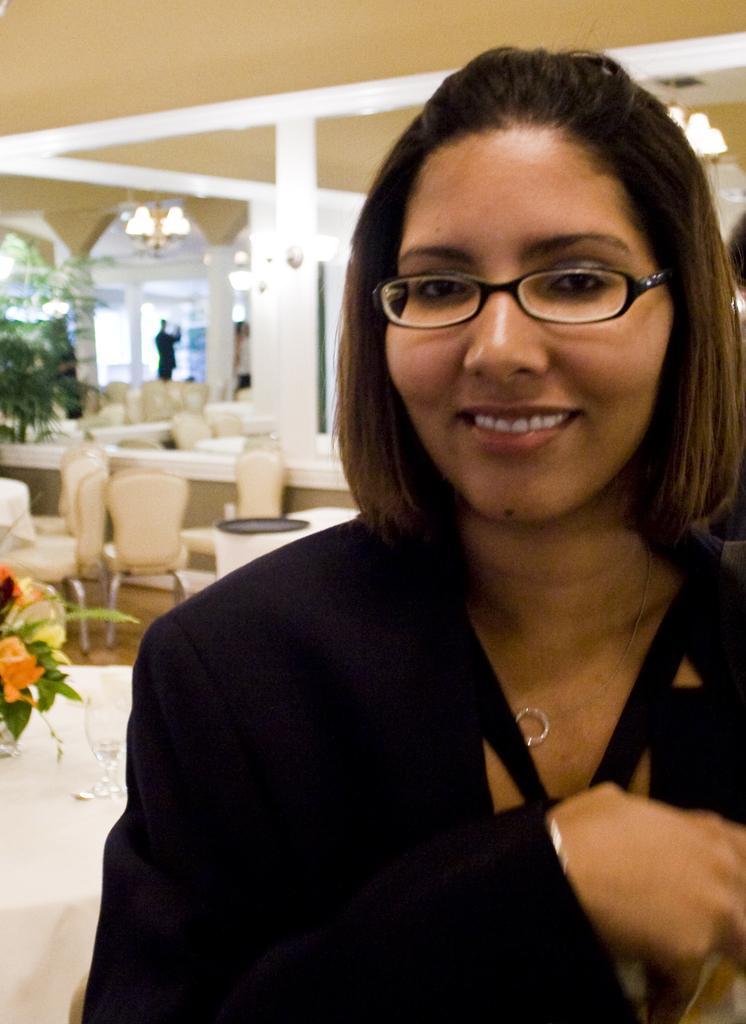In one or two sentences, can you explain what this image depicts? In the picture we can see a woman smiling, she is wearing a black dress, in the background we can find some chairs, tables and person, pillars, and ceiling and some plants with flowers. 